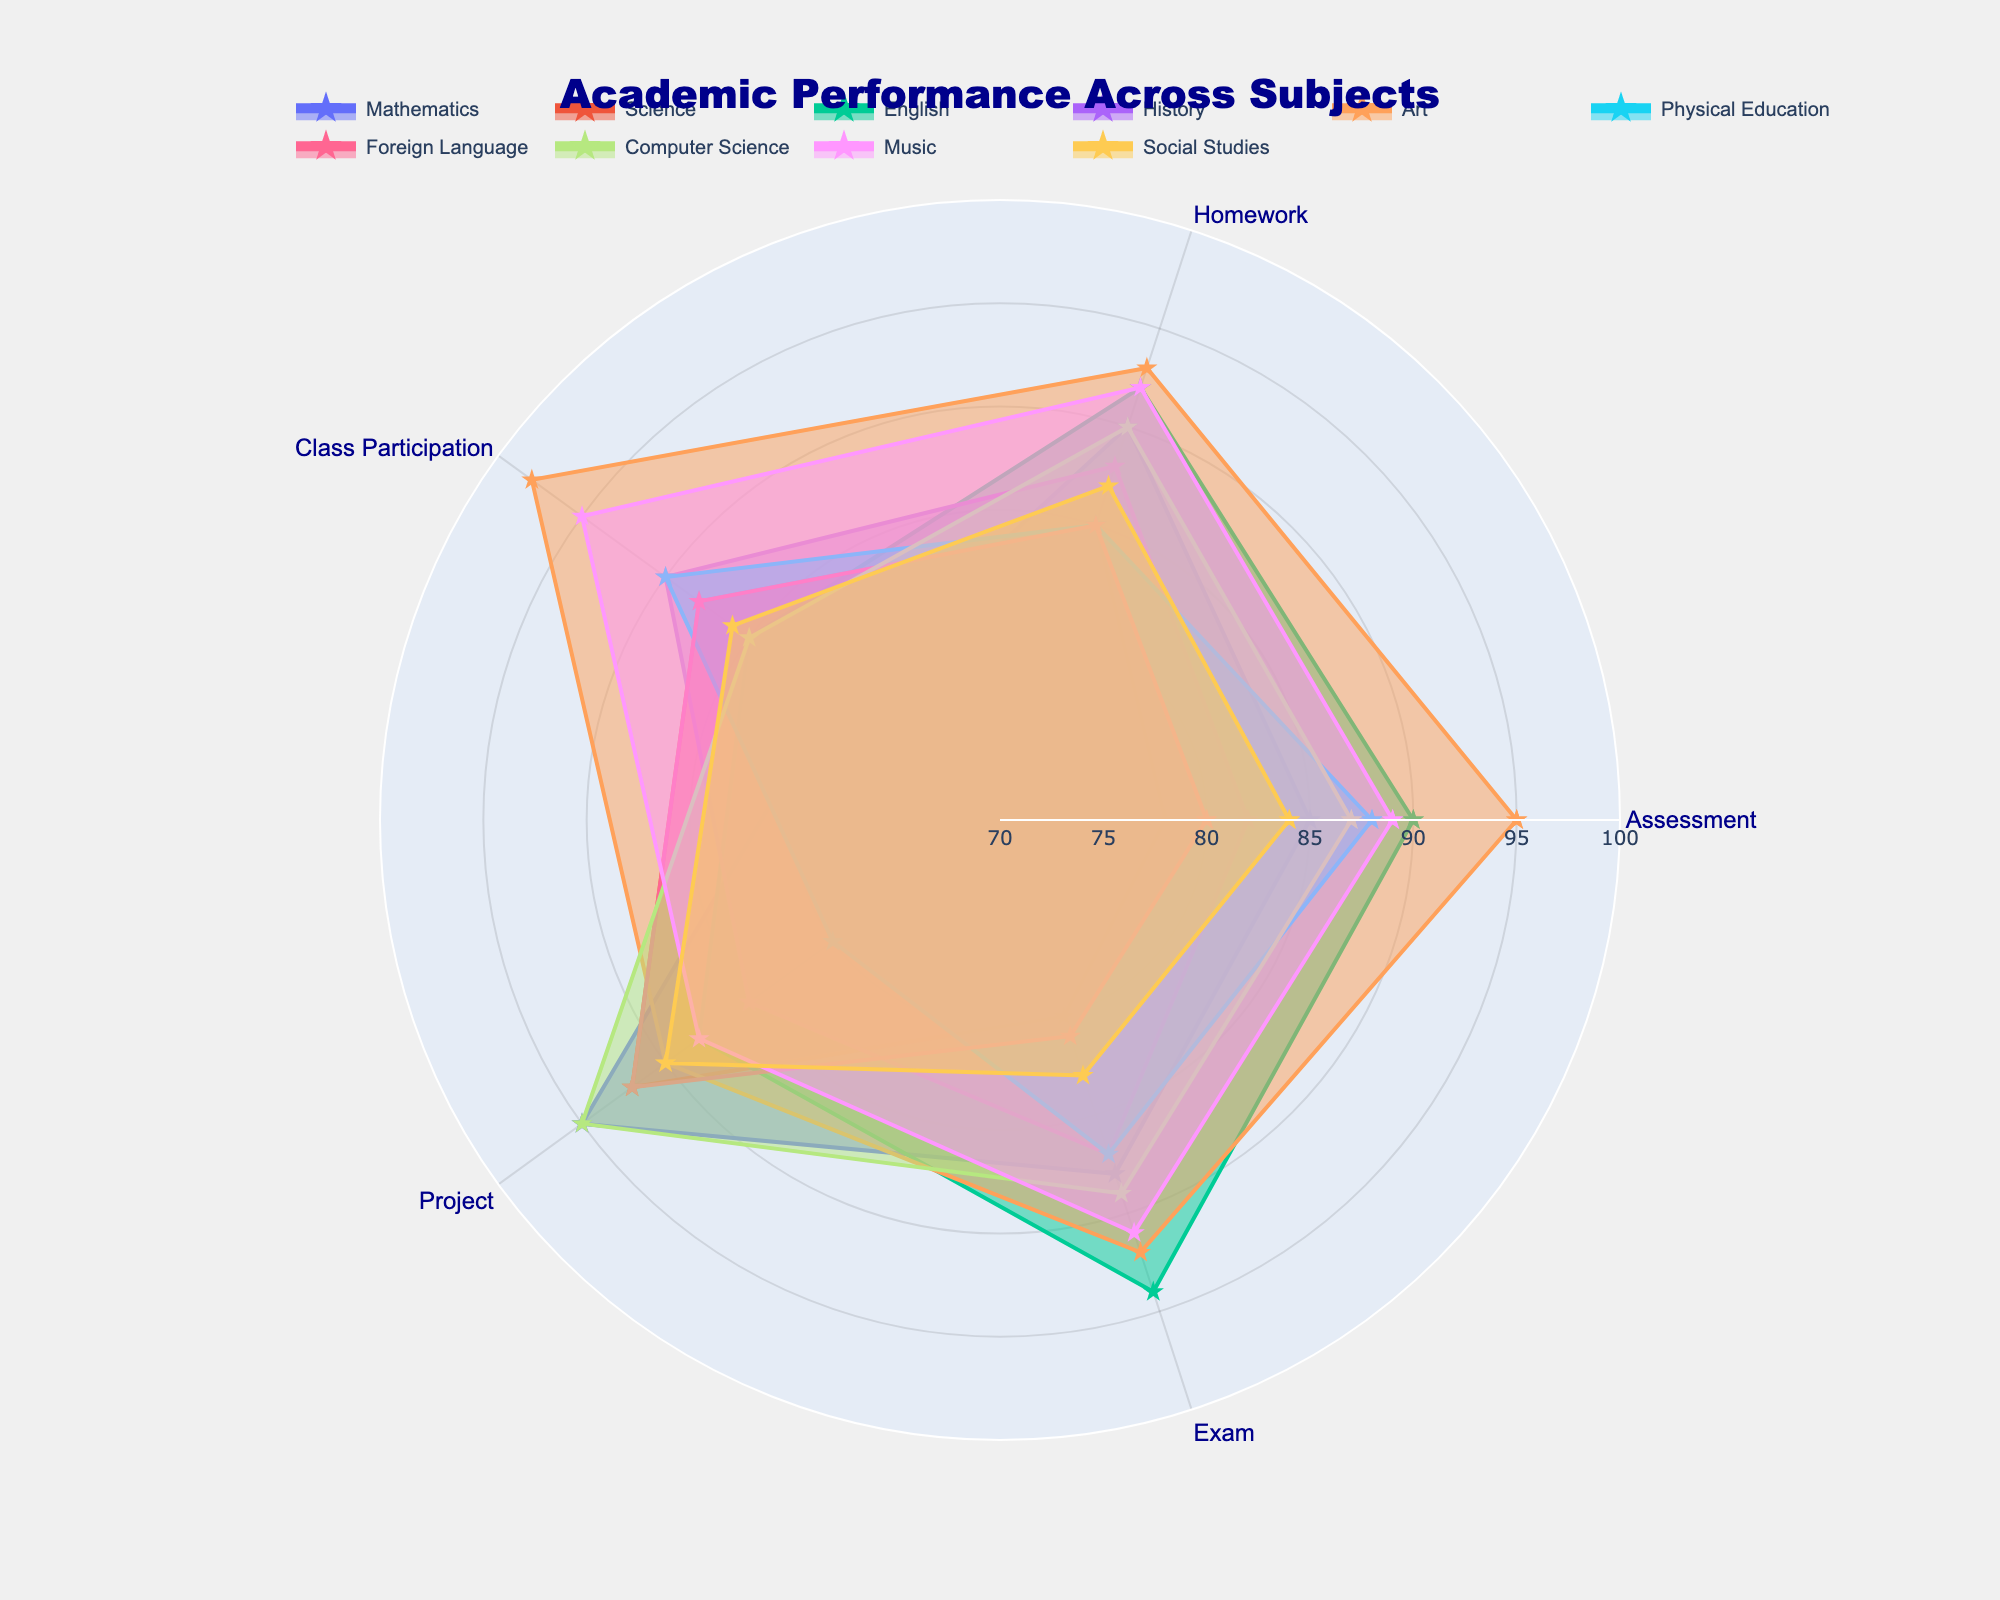What is the title of the figure? The title of the figure is mentioned at the top of the chart in a prominent font. It provides a high-level description of the data presented in the chart.
Answer: Academic Performance Across Subjects What is the assessment score for Mathematics? The radar chart shows the scores for different grading categories. Look for Mathematics on the chart and observe its value on the 'Assessment' axis.
Answer: 85 Which subject has the highest score in Homework? Check the 'Homework' axis on the radar chart and identify the subject that has the highest value marked.
Answer: Art How does Science perform in Class Participation compared to Foreign Language? Locate the points corresponding to Science and Foreign Language on the "Class Participation" axis. Compare their values by checking which one is higher or lower.
Answer: Both have the same score (85) What is the average Exam score across all subjects? Sum the 'Exam' scores for all subjects and then divide by the total number of subjects. The operation is: (88+80+94+87+92+87+81+89+91+83) / 10 = 87.2.
Answer: 87.2 Compare the Project scores of English and Computer Science and determine the difference. Find the Project scores on the radar chart for English and Computer Science. Subtract the Project score of English from that of Computer Science.
Answer: 10 (95 - 85) Which subject shows the most balanced performance across all grading categories? Look for the subject whose radar plot is closest to a regular polygon, indicating more balanced scores across all grading categories.
Answer: History What is the sum of Homework and Exam scores for Music? Add the Homework and Exam scores for Music from the radar chart. The operation is: 92 + 91.
Answer: 183 Which subject has the lowest Assessment score and what is it? Identify the subject with the lowest point on the Assessment axis.
Answer: Science (78) What are the maximum and minimum scores in Class Participation across all subjects? Find the highest and lowest points on the Class Participation axis by examining each subject’s score.
Answer: Maximum: 98 (Art), Minimum: 80 (Mathematics) 